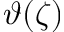Convert formula to latex. <formula><loc_0><loc_0><loc_500><loc_500>\vartheta ( \zeta )</formula> 